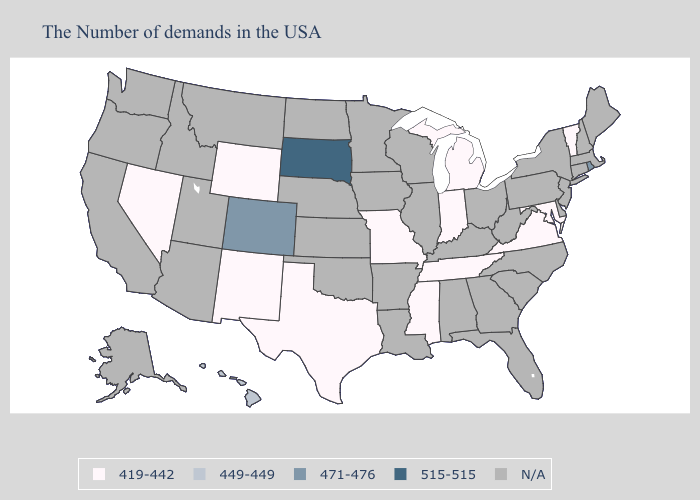What is the lowest value in the South?
Concise answer only. 419-442. Name the states that have a value in the range 515-515?
Concise answer only. South Dakota. Among the states that border South Dakota , which have the highest value?
Write a very short answer. Wyoming. Among the states that border Mississippi , which have the highest value?
Give a very brief answer. Tennessee. What is the value of Florida?
Be succinct. N/A. How many symbols are there in the legend?
Quick response, please. 5. Which states have the highest value in the USA?
Write a very short answer. South Dakota. Name the states that have a value in the range 449-449?
Keep it brief. Hawaii. What is the lowest value in the USA?
Keep it brief. 419-442. What is the value of Arkansas?
Give a very brief answer. N/A. What is the lowest value in states that border Alabama?
Keep it brief. 419-442. Does South Dakota have the highest value in the USA?
Be succinct. Yes. Name the states that have a value in the range 515-515?
Give a very brief answer. South Dakota. 